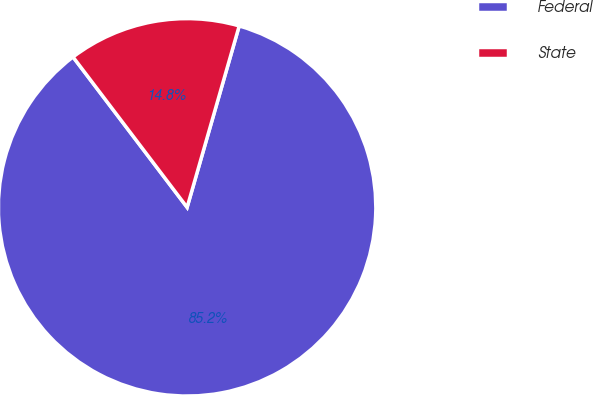Convert chart to OTSL. <chart><loc_0><loc_0><loc_500><loc_500><pie_chart><fcel>Federal<fcel>State<nl><fcel>85.22%<fcel>14.78%<nl></chart> 